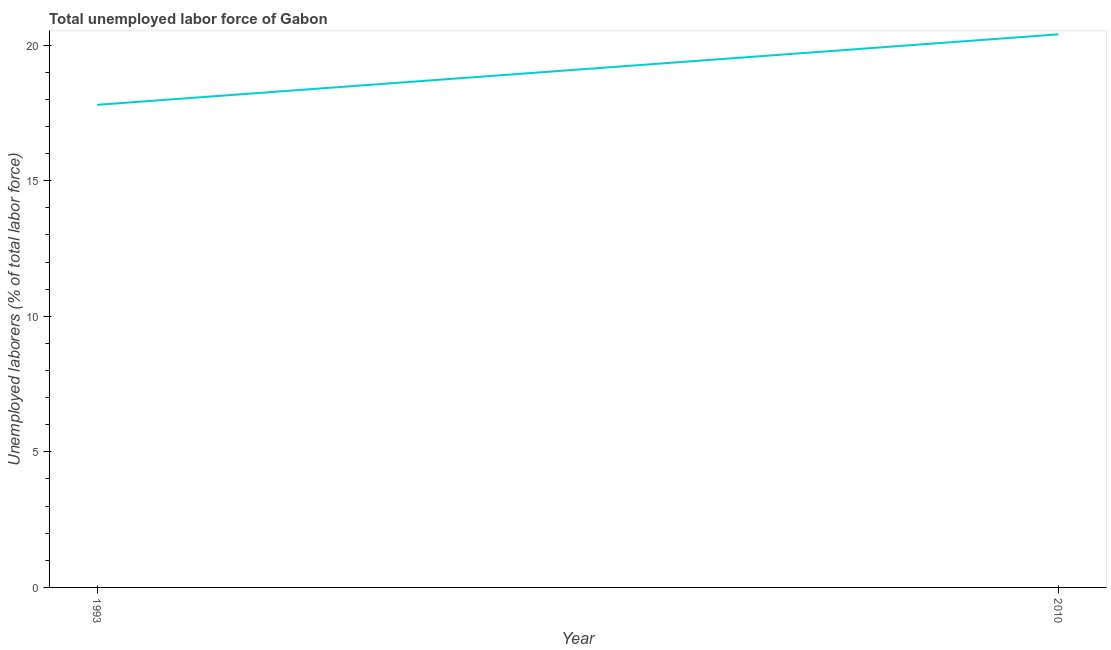What is the total unemployed labour force in 1993?
Ensure brevity in your answer.  17.8. Across all years, what is the maximum total unemployed labour force?
Offer a terse response. 20.4. Across all years, what is the minimum total unemployed labour force?
Give a very brief answer. 17.8. In which year was the total unemployed labour force minimum?
Provide a succinct answer. 1993. What is the sum of the total unemployed labour force?
Offer a very short reply. 38.2. What is the difference between the total unemployed labour force in 1993 and 2010?
Provide a short and direct response. -2.6. What is the average total unemployed labour force per year?
Provide a short and direct response. 19.1. What is the median total unemployed labour force?
Give a very brief answer. 19.1. What is the ratio of the total unemployed labour force in 1993 to that in 2010?
Provide a short and direct response. 0.87. Is the total unemployed labour force in 1993 less than that in 2010?
Your answer should be very brief. Yes. Does the total unemployed labour force monotonically increase over the years?
Keep it short and to the point. Yes. How many lines are there?
Provide a succinct answer. 1. How many years are there in the graph?
Keep it short and to the point. 2. Are the values on the major ticks of Y-axis written in scientific E-notation?
Keep it short and to the point. No. Does the graph contain grids?
Keep it short and to the point. No. What is the title of the graph?
Offer a very short reply. Total unemployed labor force of Gabon. What is the label or title of the X-axis?
Offer a very short reply. Year. What is the label or title of the Y-axis?
Provide a short and direct response. Unemployed laborers (% of total labor force). What is the Unemployed laborers (% of total labor force) in 1993?
Your answer should be very brief. 17.8. What is the Unemployed laborers (% of total labor force) in 2010?
Keep it short and to the point. 20.4. What is the ratio of the Unemployed laborers (% of total labor force) in 1993 to that in 2010?
Ensure brevity in your answer.  0.87. 